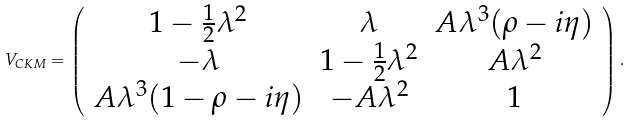Convert formula to latex. <formula><loc_0><loc_0><loc_500><loc_500>V _ { C K M } = \left ( \begin{array} { c c c } 1 - \frac { 1 } { 2 } \lambda ^ { 2 } & \lambda & A \lambda ^ { 3 } ( \rho - i \eta ) \\ - \lambda & 1 - \frac { 1 } { 2 } \lambda ^ { 2 } & A \lambda ^ { 2 } \\ A \lambda ^ { 3 } ( 1 - \rho - i \eta ) & - A \lambda ^ { 2 } & 1 \end{array} \right ) .</formula> 